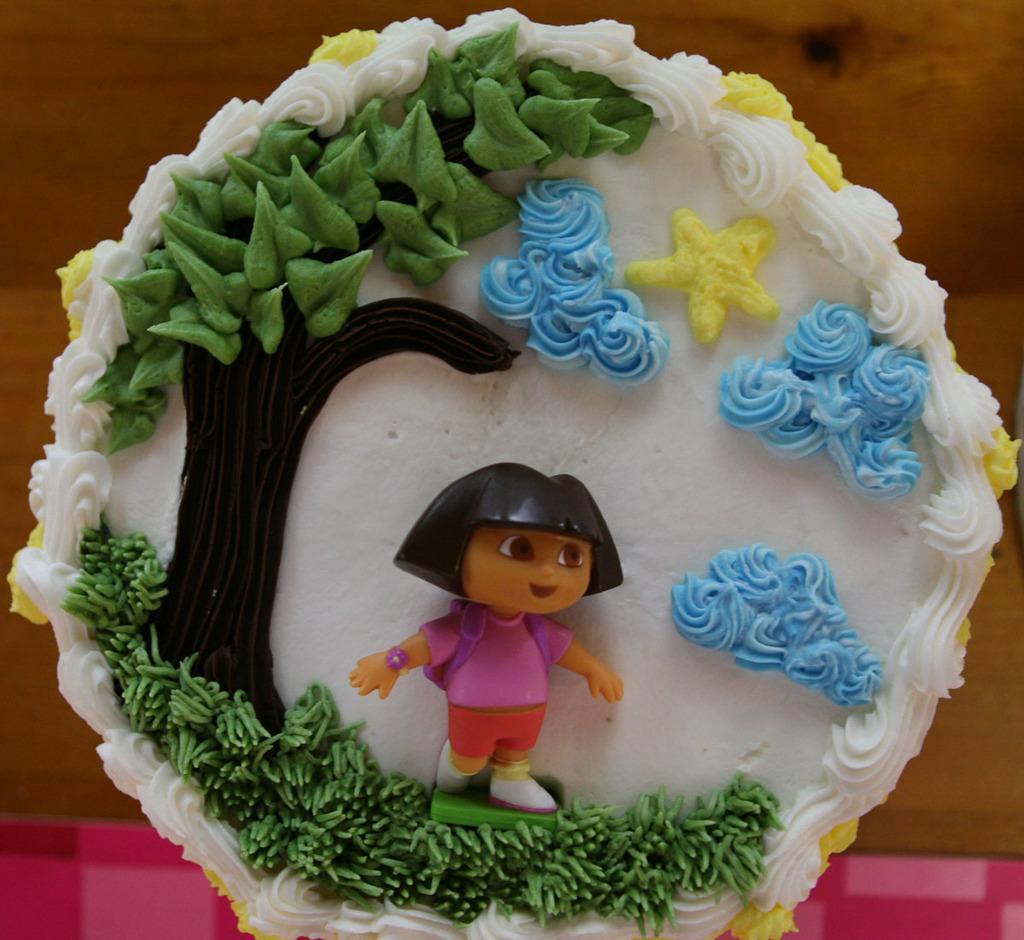Could you give a brief overview of what you see in this image? In this image there is a cake on a table. 